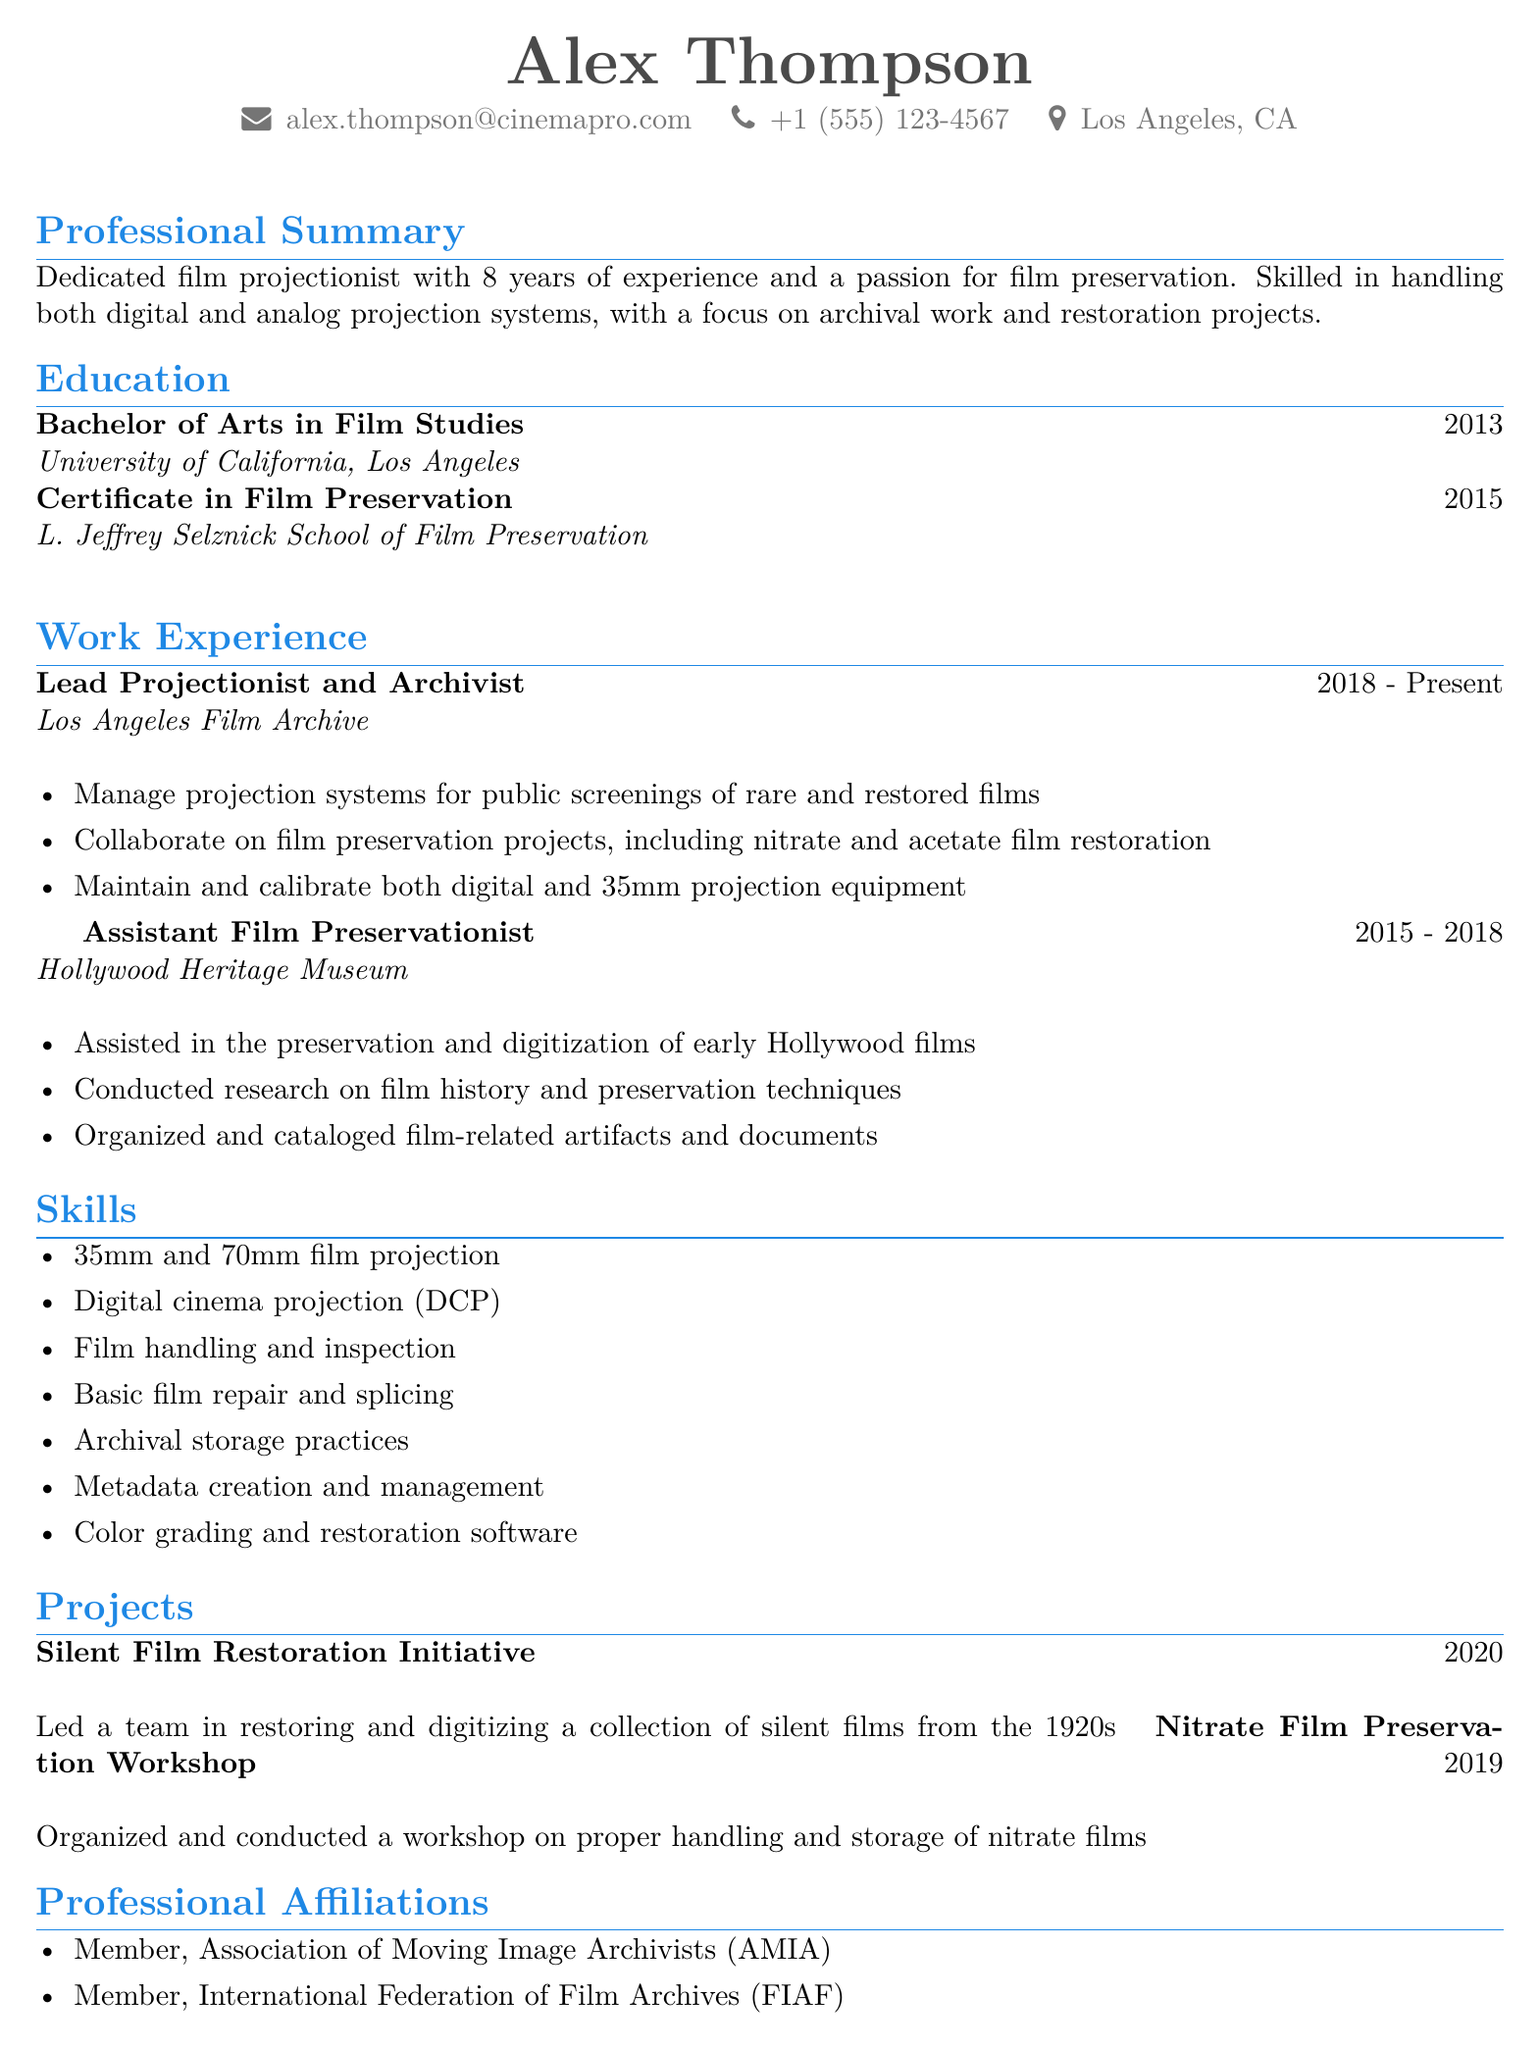What is the name of the individual? The name is listed at the top of the document under personal information.
Answer: Alex Thompson What is the primary location of the individual? The location is specified in the personal information section of the document.
Answer: Los Angeles, CA What is the degree obtained in 2015? The degree mentioned is a certificate and is found in the education section.
Answer: Certificate in Film Preservation Who is the current employer? The current position and employer are listed under the work experience section.
Answer: Los Angeles Film Archive What year did Alex lead the Silent Film Restoration Initiative? The year of the project is provided in the projects section.
Answer: 2020 Which software skills are included? The skills listed are found in the skills section of the document.
Answer: Color grading and restoration software How many years of experience does Alex have in film projection? This information is provided in the professional summary section.
Answer: 8 years What type of films did Alex assist in preserving at the Hollywood Heritage Museum? The specific type of films is mentioned in the work experience section.
Answer: Early Hollywood films What organization is Alex a member of? The affiliations are noted in the professional affiliations section.
Answer: Association of Moving Image Archivists (AMIA) 